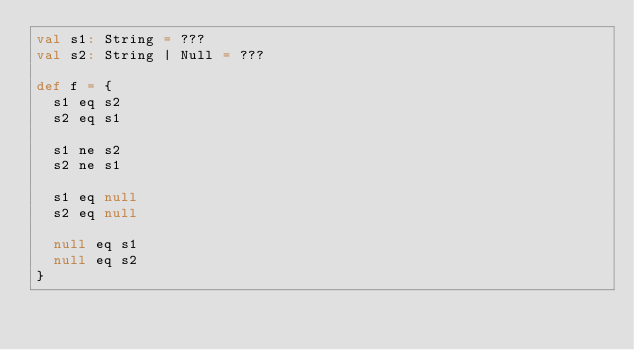<code> <loc_0><loc_0><loc_500><loc_500><_Scala_>val s1: String = ???
val s2: String | Null = ???

def f = {
  s1 eq s2
  s2 eq s1

  s1 ne s2
  s2 ne s1

  s1 eq null
  s2 eq null

  null eq s1
  null eq s2
}
</code> 